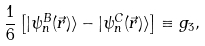Convert formula to latex. <formula><loc_0><loc_0><loc_500><loc_500>\frac { 1 } { 6 } \left [ | \psi ^ { B } _ { n } ( \vec { r } ) \rangle - | \psi ^ { C } _ { n } ( \vec { r } ) \rangle \right ] \equiv g _ { 3 } ,</formula> 